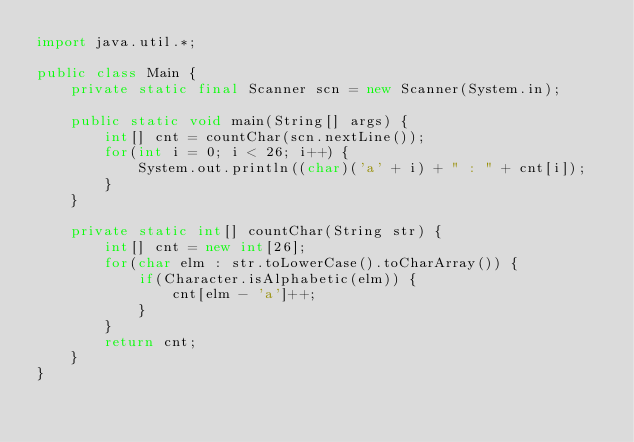<code> <loc_0><loc_0><loc_500><loc_500><_Java_>import java.util.*;

public class Main {
    private static final Scanner scn = new Scanner(System.in);
    
    public static void main(String[] args) {
        int[] cnt = countChar(scn.nextLine());
        for(int i = 0; i < 26; i++) {
            System.out.println((char)('a' + i) + " : " + cnt[i]);
        }
    }
    
    private static int[] countChar(String str) {
        int[] cnt = new int[26];
        for(char elm : str.toLowerCase().toCharArray()) {
            if(Character.isAlphabetic(elm)) {
                cnt[elm - 'a']++;
            }
        }
        return cnt;
    }
}</code> 